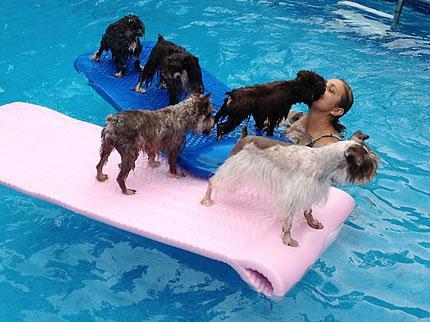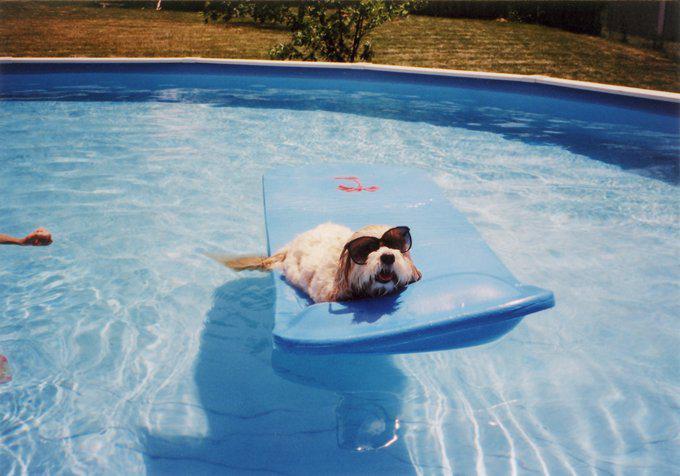The first image is the image on the left, the second image is the image on the right. For the images displayed, is the sentence "At least one dog is in an inner tube." factually correct? Answer yes or no. No. 